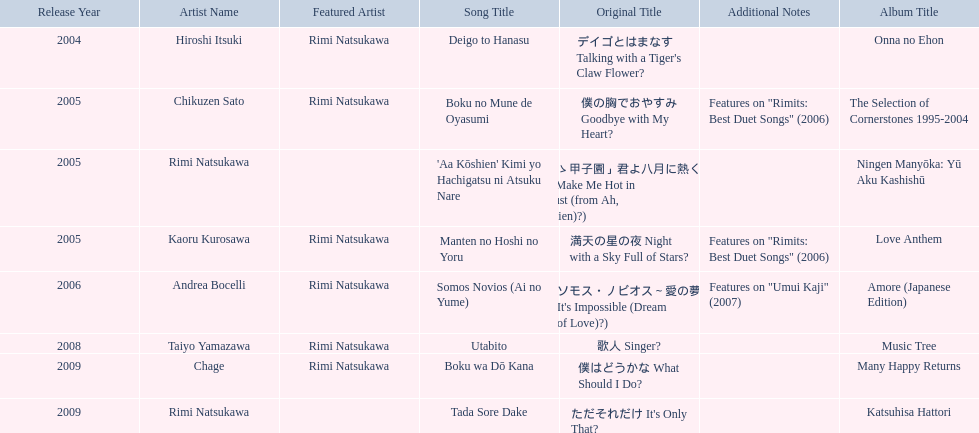How many titles have only one artist? 2. 